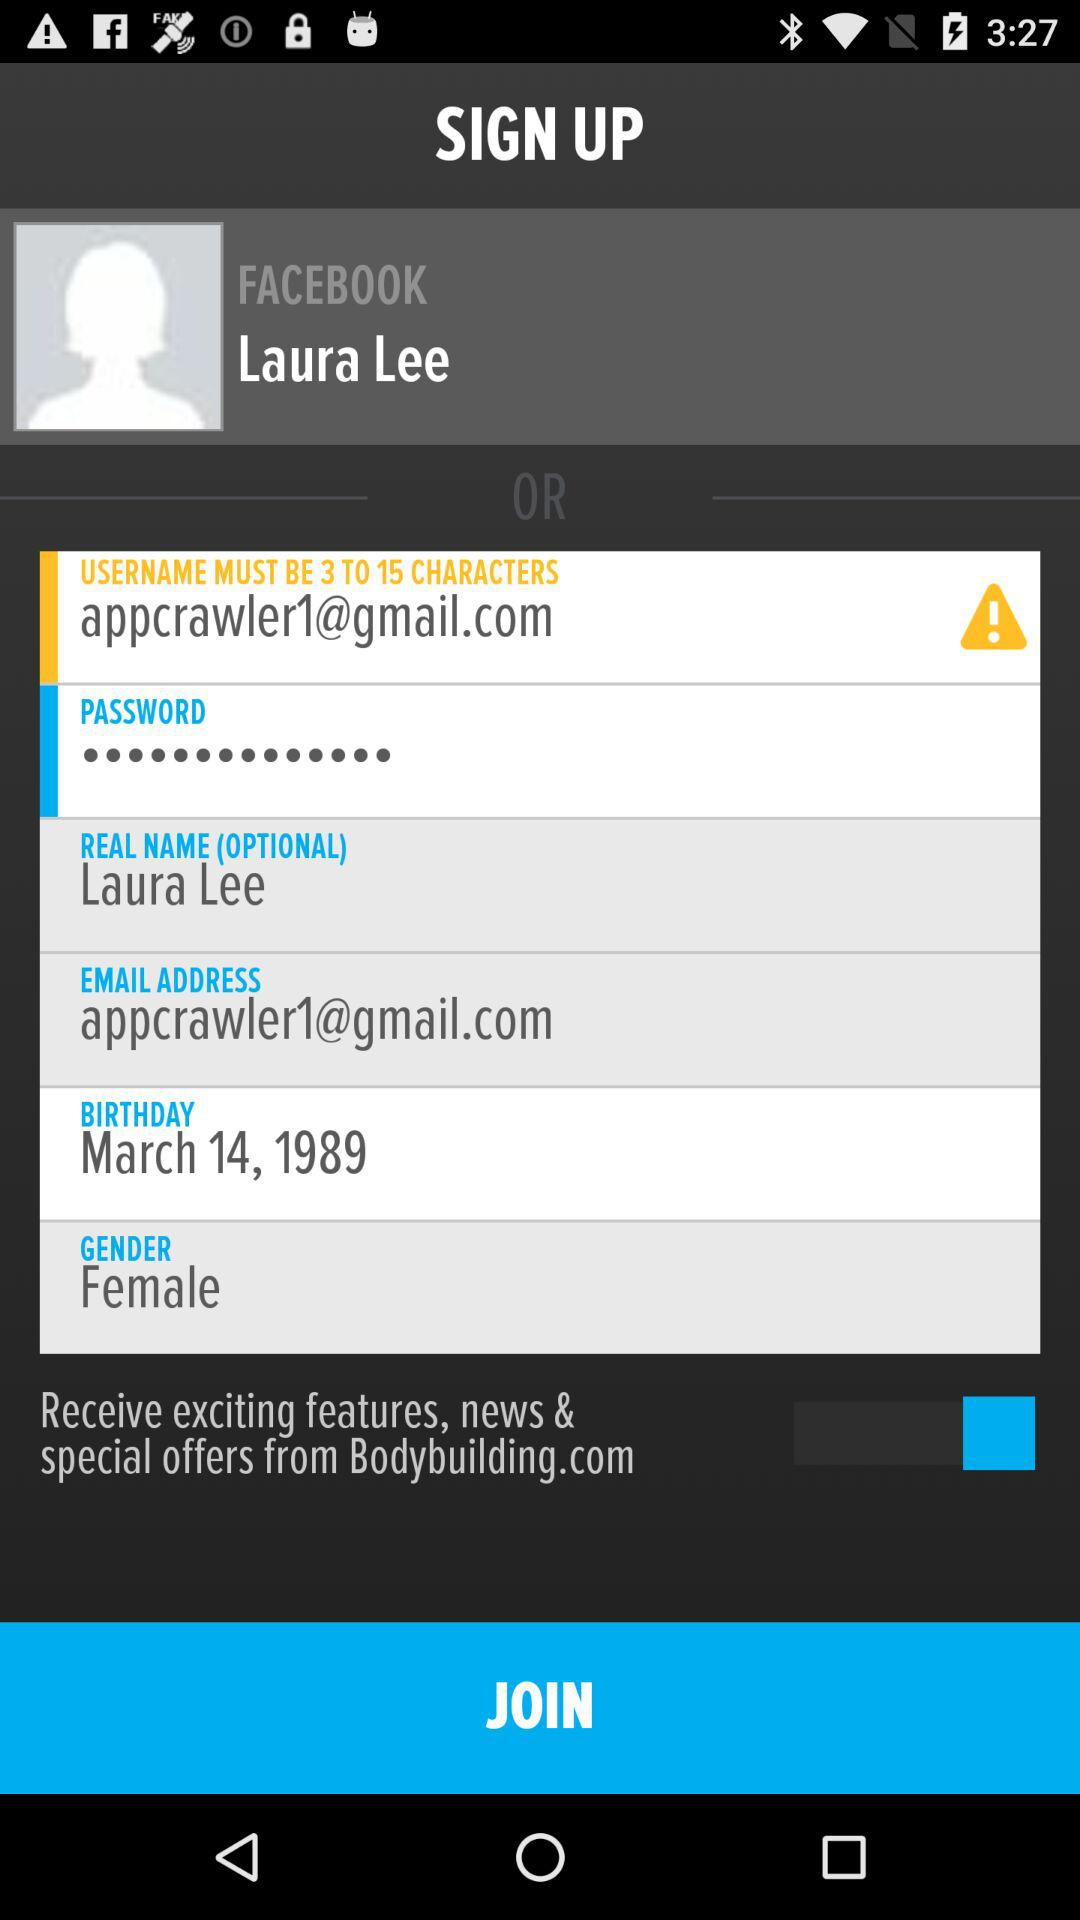What is the email address? The email address is appcrawler1@gmail.com. 